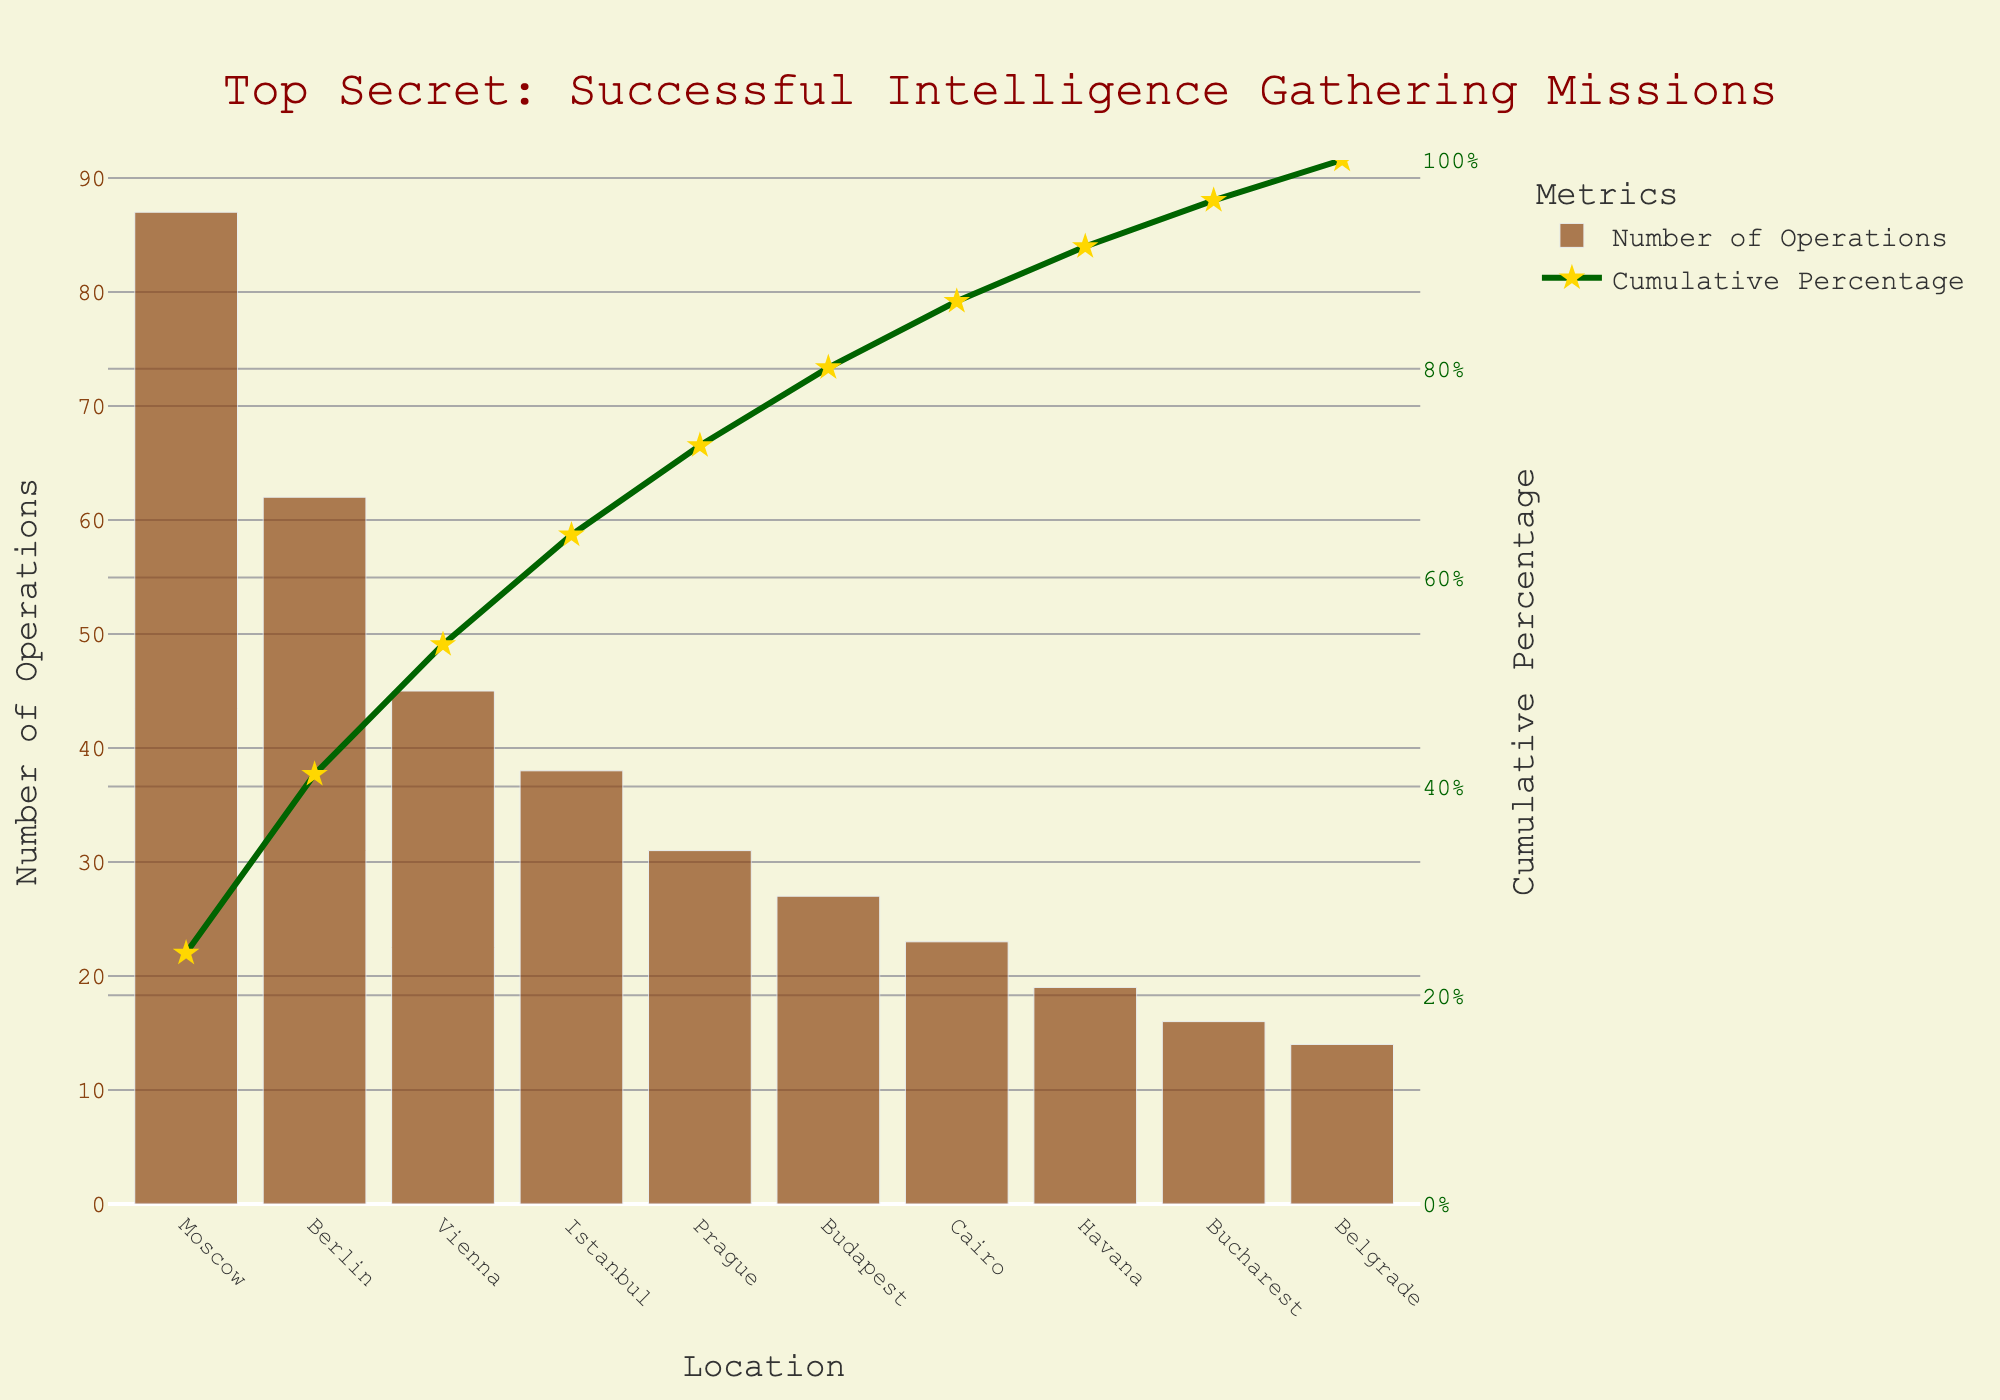Which location has the highest number of intelligence gathering operations? The location with the highest bar represents the highest number of operations. This is the bar on the far left, labeled 'Moscow.'
Answer: Moscow What is the title of this chart? The title is written at the top of the chart. It reads "Top Secret: Successful Intelligence Gathering Missions."
Answer: Top Secret: Successful Intelligence Gathering Missions How many locations are displayed in the chart? Count the number of different bars along the x-axis, each representing a location. There are 10 bars.
Answer: 10 Which location has the lowest number of intelligence gathering operations? The location with the lowest bar represents the lowest number of operations. This is the bar on the far right, labeled 'Belgrade.'
Answer: Belgrade What is the cumulative percentage of operations up to and including Vienna? Look at the cumulative percentage line for the data point corresponding to Vienna. The value is listed as the cumulative percentage for Vienna.
Answer: Approximately 68.4% What is the cumulative percentage after adding the operations in Istanbul? The cumulative percentage curve indicates the accumulation in percentage. Adding Istanbul would make it Vienna + Istanbul. The cumulative percentage at Istanbul is around 71.8%.
Answer: Approximately 71.8% How does the number of operations in Berlin compare to those in Budapest? Look at the height of the bars for Berlin and Budapest. Berlin's bar is significantly higher than Budapest's.
Answer: Berlin has more operations than Budapest What is the color of the bars representing the number of operations? Observe the color filling of the bars, which is brown.
Answer: Brown Is the cumulative percentage line always increasing? Follow the cumulative line from left to right across all points. It consistently rises as more data points are added.
Answer: Yes What percentage of the operations are represented by the top two locations? Add the operations of Moscow (87) and Berlin (62) and find their percentage of the total. (87 + 62) / (total number) * 100 = (87 + 62) / 362 * 100 = 41.1%
Answer: Approximately 41.1% 